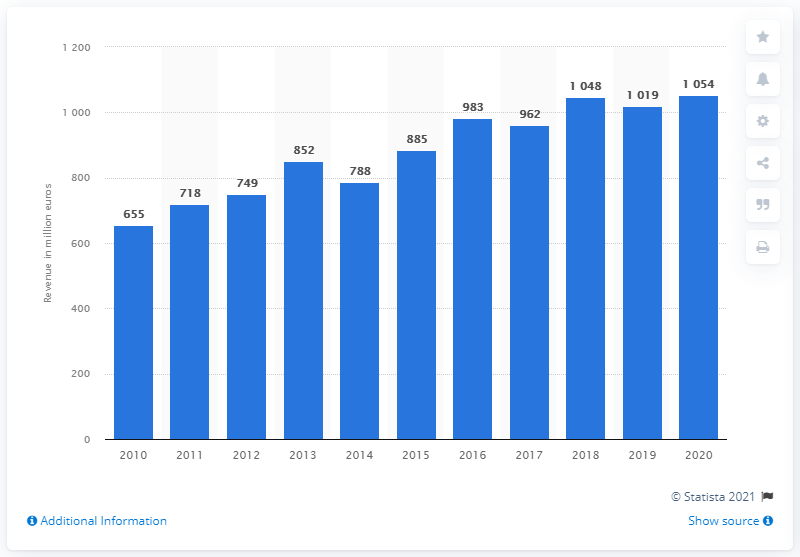Give some essential details in this illustration. In 2020, the Finnish government collected a total of 1054 million euros in tobacco excise tax revenue. 